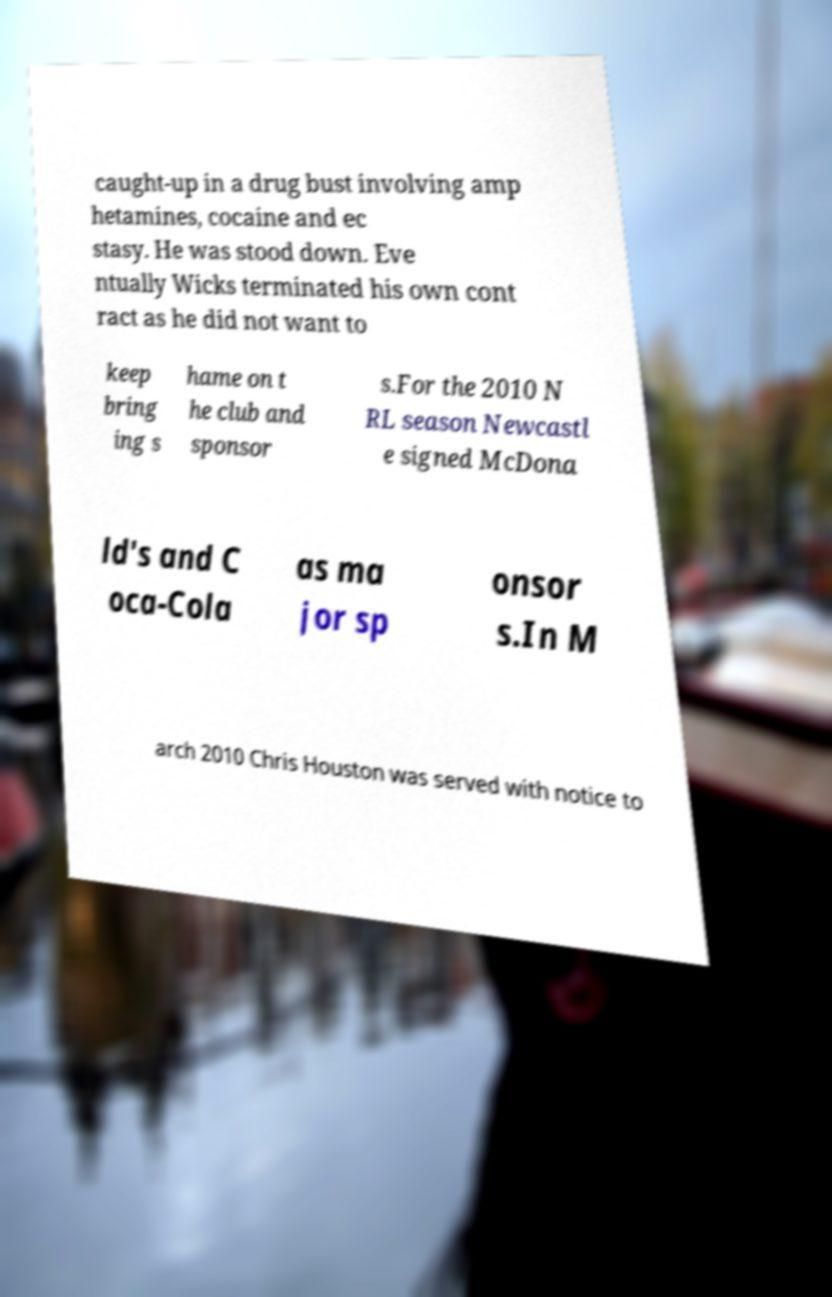What messages or text are displayed in this image? I need them in a readable, typed format. caught-up in a drug bust involving amp hetamines, cocaine and ec stasy. He was stood down. Eve ntually Wicks terminated his own cont ract as he did not want to keep bring ing s hame on t he club and sponsor s.For the 2010 N RL season Newcastl e signed McDona ld's and C oca-Cola as ma jor sp onsor s.In M arch 2010 Chris Houston was served with notice to 